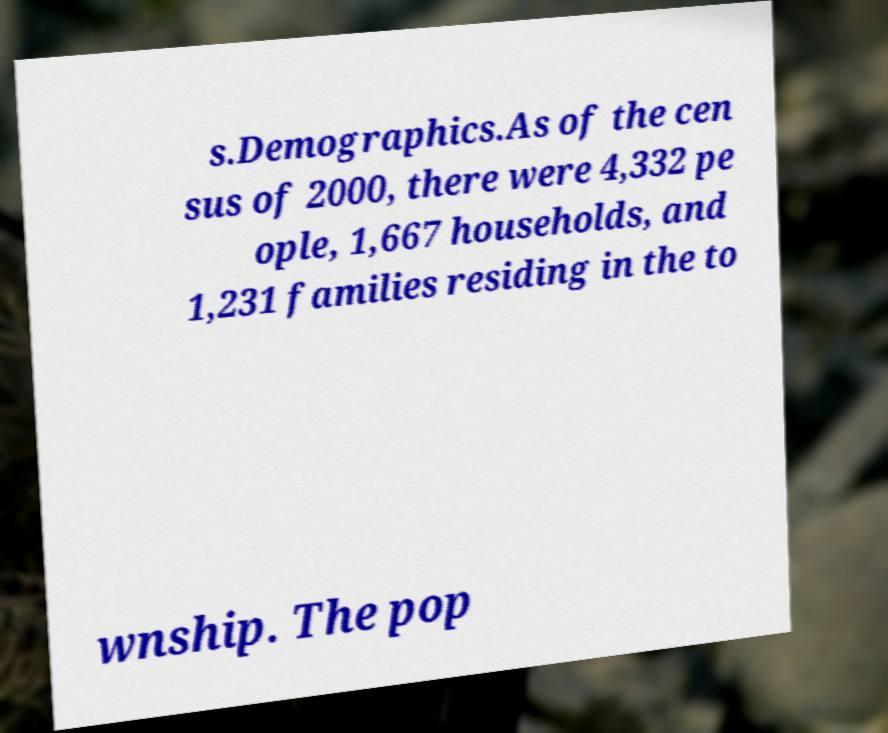Can you read and provide the text displayed in the image?This photo seems to have some interesting text. Can you extract and type it out for me? s.Demographics.As of the cen sus of 2000, there were 4,332 pe ople, 1,667 households, and 1,231 families residing in the to wnship. The pop 